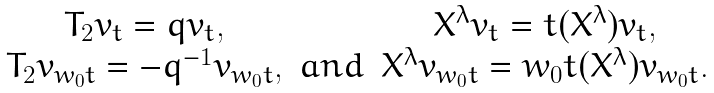Convert formula to latex. <formula><loc_0><loc_0><loc_500><loc_500>\begin{matrix} T _ { 2 } v _ { t } = q v _ { t } , & \quad & X ^ { \lambda } v _ { t } = t ( X ^ { \lambda } ) v _ { t } , \\ T _ { 2 } v _ { w _ { 0 } t } = - q ^ { - 1 } v _ { w _ { 0 } t } , & a n d & X ^ { \lambda } v _ { w _ { 0 } t } = w _ { 0 } t ( X ^ { \lambda } ) v _ { w _ { 0 } t } . \end{matrix}</formula> 